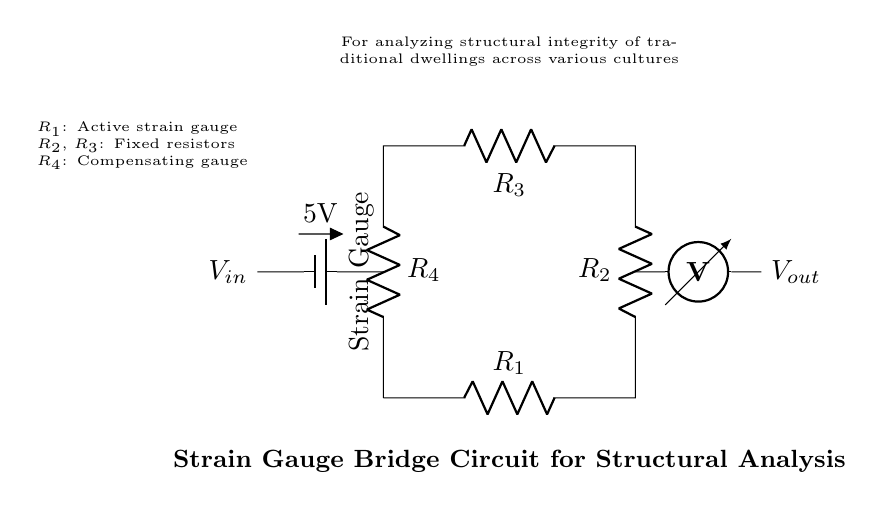What type of circuit is represented here? This circuit is a bridge circuit, which is characterized by its configuration that allows it to measure small changes in resistance due to the strain on the gauges.
Answer: Bridge circuit What is the input voltage of the circuit? The circuit diagram indicates a battery with a label of 5V, which signifies the voltage supplied to the bridge.
Answer: 5V What resistors are present in the circuit? The resistors shown are labeled as R1, R2, R3, and R4, indicating that there are four resistors in total.
Answer: R1, R2, R3, R4 What is the role of R1 in the bridge circuit? R1 is identified as the active strain gauge, which changes its resistance in response to strain, thereby affecting the balance of the bridge.
Answer: Active strain gauge How does the output voltage relate to the input voltage? The output voltage is determined relative to the state of the bridge balance created by the resistors; any imbalance will affect the voltage reading across the voltmeter connected to the circuit.
Answer: Dependent on bridge balance What is the function of the strain gauge in this circuit? The strain gauge measures mechanical deformation, which changes its resistance and influences the bridge's balance, allowing for assessment of structural integrity.
Answer: Measure mechanical deformation 